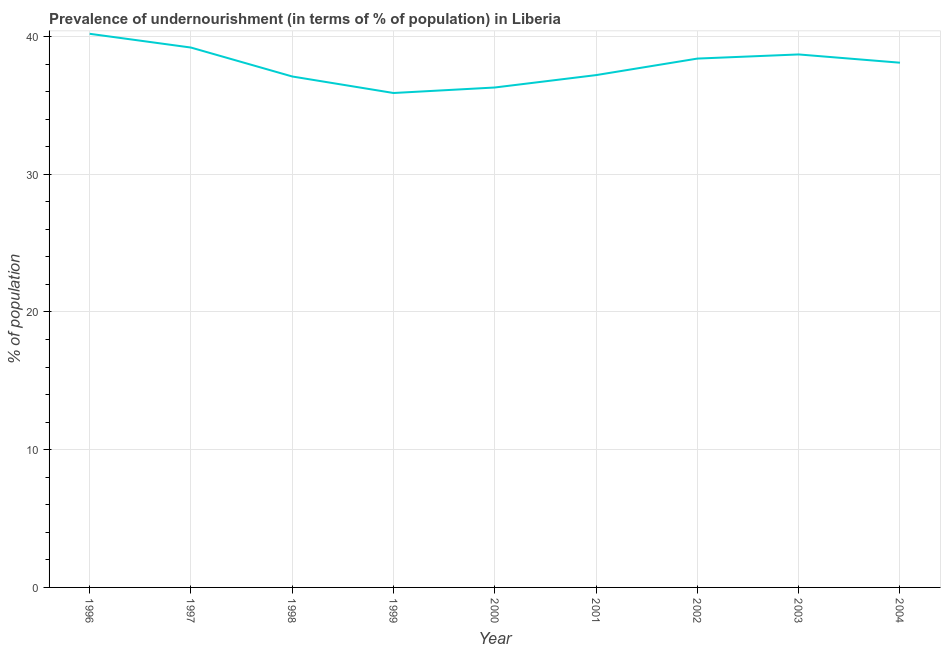What is the percentage of undernourished population in 2002?
Give a very brief answer. 38.4. Across all years, what is the maximum percentage of undernourished population?
Ensure brevity in your answer.  40.2. Across all years, what is the minimum percentage of undernourished population?
Keep it short and to the point. 35.9. In which year was the percentage of undernourished population maximum?
Offer a very short reply. 1996. What is the sum of the percentage of undernourished population?
Offer a terse response. 341.1. What is the difference between the percentage of undernourished population in 1999 and 2000?
Offer a terse response. -0.4. What is the average percentage of undernourished population per year?
Your answer should be compact. 37.9. What is the median percentage of undernourished population?
Your answer should be very brief. 38.1. In how many years, is the percentage of undernourished population greater than 8 %?
Offer a very short reply. 9. What is the ratio of the percentage of undernourished population in 2000 to that in 2002?
Offer a very short reply. 0.95. Is the percentage of undernourished population in 1998 less than that in 2000?
Your answer should be compact. No. Is the difference between the percentage of undernourished population in 1997 and 1998 greater than the difference between any two years?
Your answer should be compact. No. Is the sum of the percentage of undernourished population in 1996 and 2001 greater than the maximum percentage of undernourished population across all years?
Your response must be concise. Yes. What is the difference between the highest and the lowest percentage of undernourished population?
Provide a short and direct response. 4.3. How many years are there in the graph?
Offer a very short reply. 9. Does the graph contain any zero values?
Provide a succinct answer. No. Does the graph contain grids?
Your response must be concise. Yes. What is the title of the graph?
Provide a short and direct response. Prevalence of undernourishment (in terms of % of population) in Liberia. What is the label or title of the X-axis?
Make the answer very short. Year. What is the label or title of the Y-axis?
Your answer should be very brief. % of population. What is the % of population in 1996?
Your answer should be compact. 40.2. What is the % of population in 1997?
Ensure brevity in your answer.  39.2. What is the % of population of 1998?
Give a very brief answer. 37.1. What is the % of population of 1999?
Give a very brief answer. 35.9. What is the % of population of 2000?
Give a very brief answer. 36.3. What is the % of population of 2001?
Your response must be concise. 37.2. What is the % of population in 2002?
Offer a terse response. 38.4. What is the % of population of 2003?
Give a very brief answer. 38.7. What is the % of population in 2004?
Make the answer very short. 38.1. What is the difference between the % of population in 1996 and 1997?
Your answer should be very brief. 1. What is the difference between the % of population in 1996 and 2001?
Keep it short and to the point. 3. What is the difference between the % of population in 1996 and 2002?
Provide a short and direct response. 1.8. What is the difference between the % of population in 1996 and 2003?
Your answer should be very brief. 1.5. What is the difference between the % of population in 1996 and 2004?
Offer a terse response. 2.1. What is the difference between the % of population in 1997 and 1998?
Make the answer very short. 2.1. What is the difference between the % of population in 1997 and 2000?
Provide a succinct answer. 2.9. What is the difference between the % of population in 1997 and 2002?
Offer a very short reply. 0.8. What is the difference between the % of population in 1997 and 2003?
Your answer should be compact. 0.5. What is the difference between the % of population in 1998 and 2000?
Provide a short and direct response. 0.8. What is the difference between the % of population in 1998 and 2001?
Your answer should be very brief. -0.1. What is the difference between the % of population in 1999 and 2000?
Your response must be concise. -0.4. What is the difference between the % of population in 1999 and 2001?
Offer a terse response. -1.3. What is the difference between the % of population in 1999 and 2004?
Give a very brief answer. -2.2. What is the difference between the % of population in 2000 and 2001?
Offer a terse response. -0.9. What is the difference between the % of population in 2000 and 2002?
Keep it short and to the point. -2.1. What is the difference between the % of population in 2000 and 2003?
Offer a terse response. -2.4. What is the difference between the % of population in 2001 and 2003?
Provide a succinct answer. -1.5. What is the difference between the % of population in 2001 and 2004?
Your answer should be compact. -0.9. What is the difference between the % of population in 2002 and 2003?
Provide a succinct answer. -0.3. What is the ratio of the % of population in 1996 to that in 1997?
Your response must be concise. 1.03. What is the ratio of the % of population in 1996 to that in 1998?
Keep it short and to the point. 1.08. What is the ratio of the % of population in 1996 to that in 1999?
Your answer should be compact. 1.12. What is the ratio of the % of population in 1996 to that in 2000?
Your answer should be compact. 1.11. What is the ratio of the % of population in 1996 to that in 2001?
Provide a succinct answer. 1.08. What is the ratio of the % of population in 1996 to that in 2002?
Keep it short and to the point. 1.05. What is the ratio of the % of population in 1996 to that in 2003?
Offer a terse response. 1.04. What is the ratio of the % of population in 1996 to that in 2004?
Give a very brief answer. 1.05. What is the ratio of the % of population in 1997 to that in 1998?
Make the answer very short. 1.06. What is the ratio of the % of population in 1997 to that in 1999?
Offer a terse response. 1.09. What is the ratio of the % of population in 1997 to that in 2001?
Your answer should be compact. 1.05. What is the ratio of the % of population in 1997 to that in 2002?
Provide a short and direct response. 1.02. What is the ratio of the % of population in 1997 to that in 2003?
Offer a terse response. 1.01. What is the ratio of the % of population in 1998 to that in 1999?
Your response must be concise. 1.03. What is the ratio of the % of population in 1998 to that in 2002?
Provide a succinct answer. 0.97. What is the ratio of the % of population in 1998 to that in 2003?
Your answer should be very brief. 0.96. What is the ratio of the % of population in 1998 to that in 2004?
Make the answer very short. 0.97. What is the ratio of the % of population in 1999 to that in 2000?
Provide a short and direct response. 0.99. What is the ratio of the % of population in 1999 to that in 2002?
Your answer should be compact. 0.94. What is the ratio of the % of population in 1999 to that in 2003?
Your response must be concise. 0.93. What is the ratio of the % of population in 1999 to that in 2004?
Your answer should be compact. 0.94. What is the ratio of the % of population in 2000 to that in 2002?
Your response must be concise. 0.94. What is the ratio of the % of population in 2000 to that in 2003?
Offer a very short reply. 0.94. What is the ratio of the % of population in 2000 to that in 2004?
Give a very brief answer. 0.95. What is the ratio of the % of population in 2003 to that in 2004?
Your answer should be compact. 1.02. 